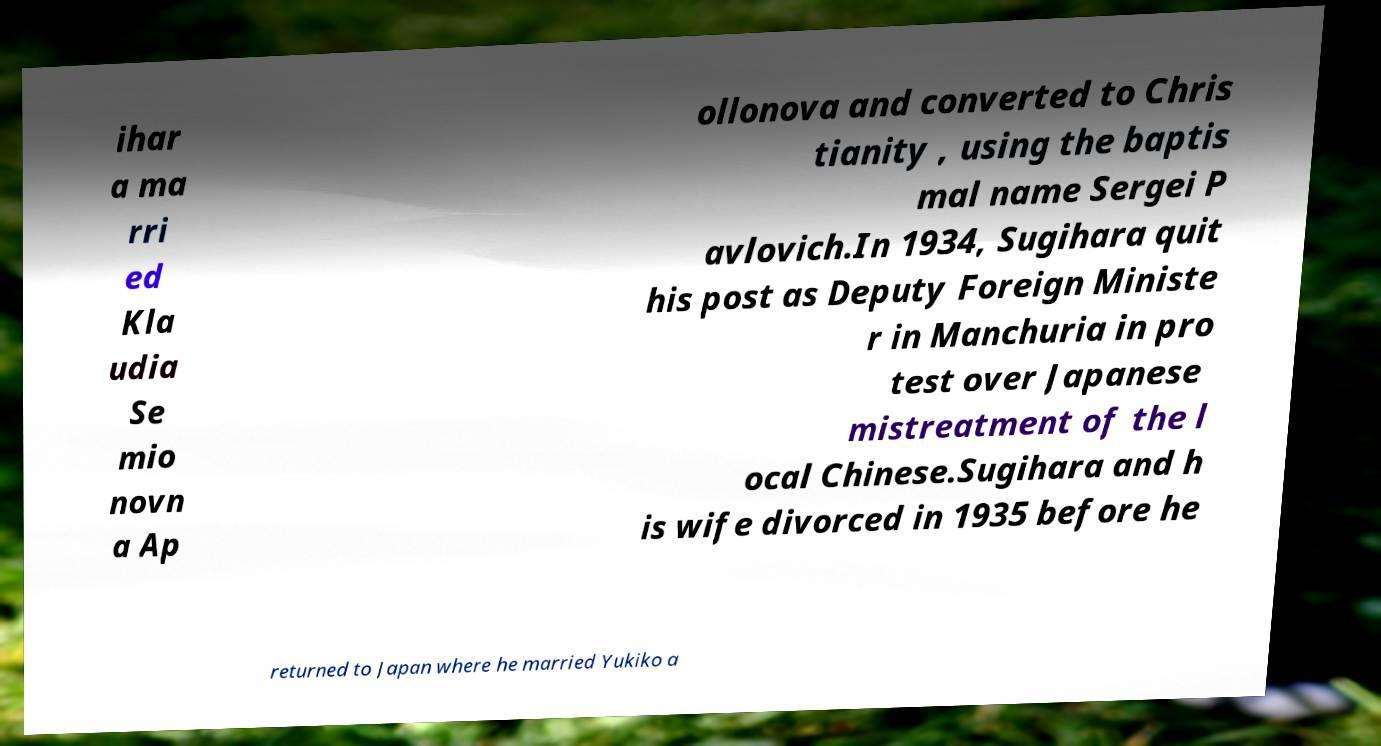Can you accurately transcribe the text from the provided image for me? ihar a ma rri ed Kla udia Se mio novn a Ap ollonova and converted to Chris tianity , using the baptis mal name Sergei P avlovich.In 1934, Sugihara quit his post as Deputy Foreign Ministe r in Manchuria in pro test over Japanese mistreatment of the l ocal Chinese.Sugihara and h is wife divorced in 1935 before he returned to Japan where he married Yukiko a 